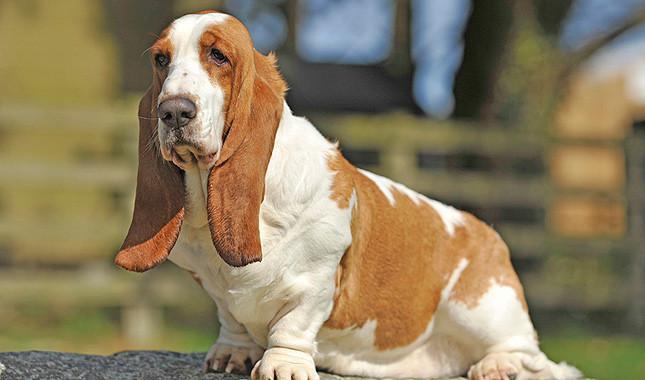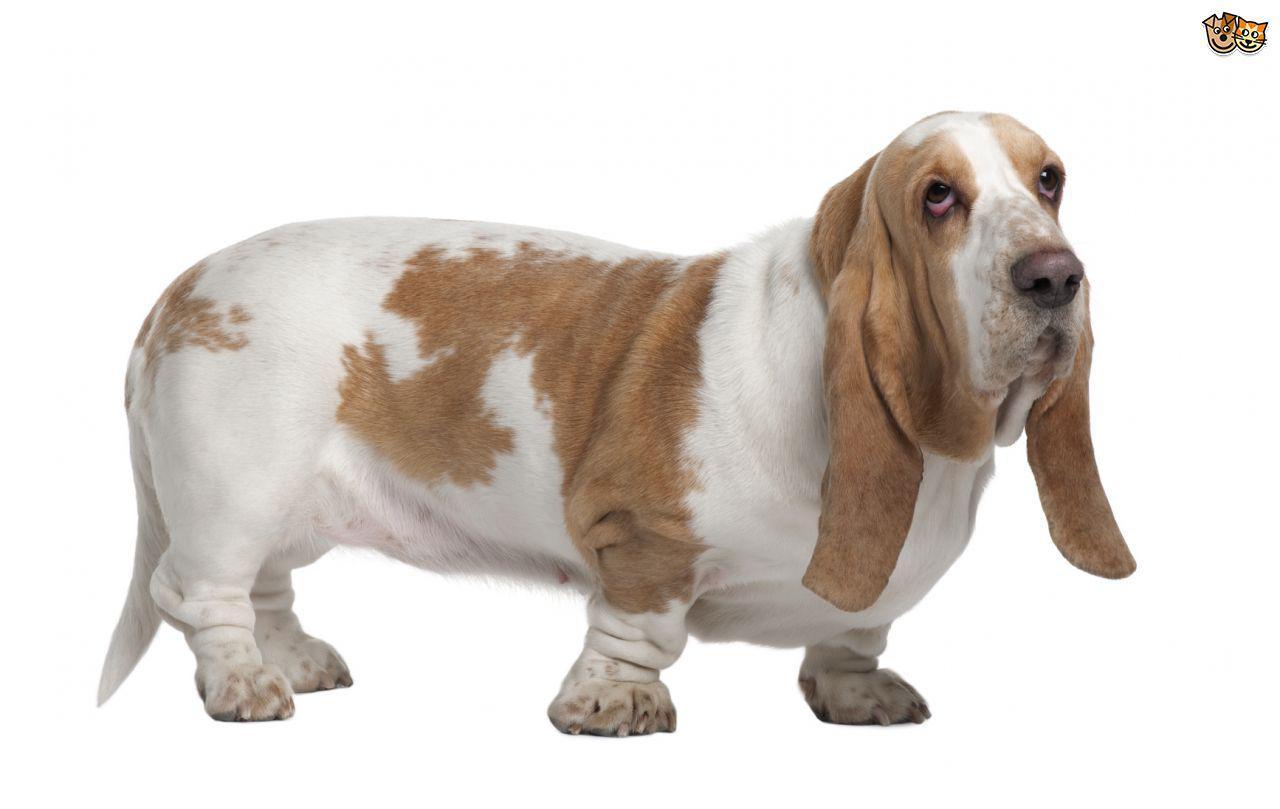The first image is the image on the left, the second image is the image on the right. Assess this claim about the two images: "One of the images contains two or more basset hounds.". Correct or not? Answer yes or no. No. 